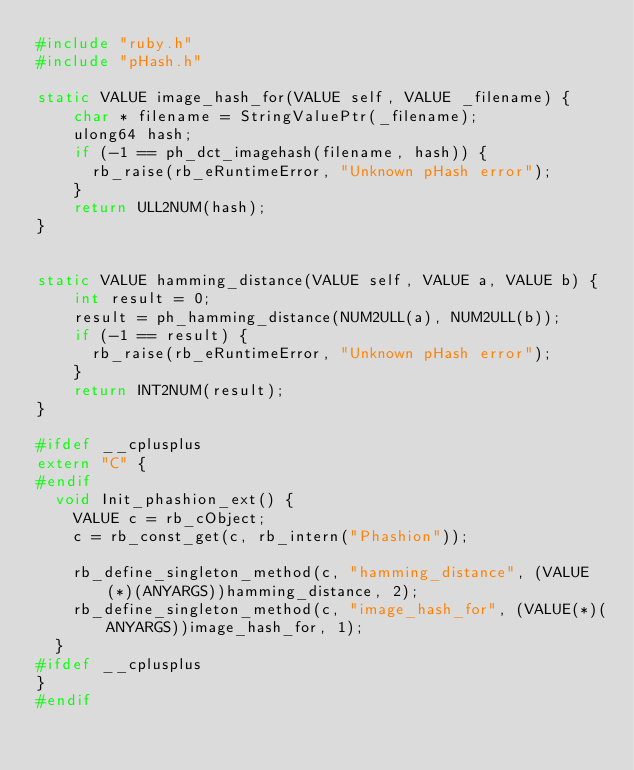Convert code to text. <code><loc_0><loc_0><loc_500><loc_500><_C_>#include "ruby.h"
#include "pHash.h"

static VALUE image_hash_for(VALUE self, VALUE _filename) {
    char * filename = StringValuePtr(_filename);
    ulong64 hash;
    if (-1 == ph_dct_imagehash(filename, hash)) {
      rb_raise(rb_eRuntimeError, "Unknown pHash error");
    }
    return ULL2NUM(hash);
}


static VALUE hamming_distance(VALUE self, VALUE a, VALUE b) {
    int result = 0;
    result = ph_hamming_distance(NUM2ULL(a), NUM2ULL(b));
    if (-1 == result) {
      rb_raise(rb_eRuntimeError, "Unknown pHash error");
    }
    return INT2NUM(result);
}

#ifdef __cplusplus
extern "C" {
#endif
  void Init_phashion_ext() {
    VALUE c = rb_cObject;
    c = rb_const_get(c, rb_intern("Phashion"));

    rb_define_singleton_method(c, "hamming_distance", (VALUE(*)(ANYARGS))hamming_distance, 2);
    rb_define_singleton_method(c, "image_hash_for", (VALUE(*)(ANYARGS))image_hash_for, 1);
  }
#ifdef __cplusplus
}
#endif
</code> 